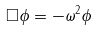Convert formula to latex. <formula><loc_0><loc_0><loc_500><loc_500>\Box \phi = - \omega ^ { 2 } \phi</formula> 